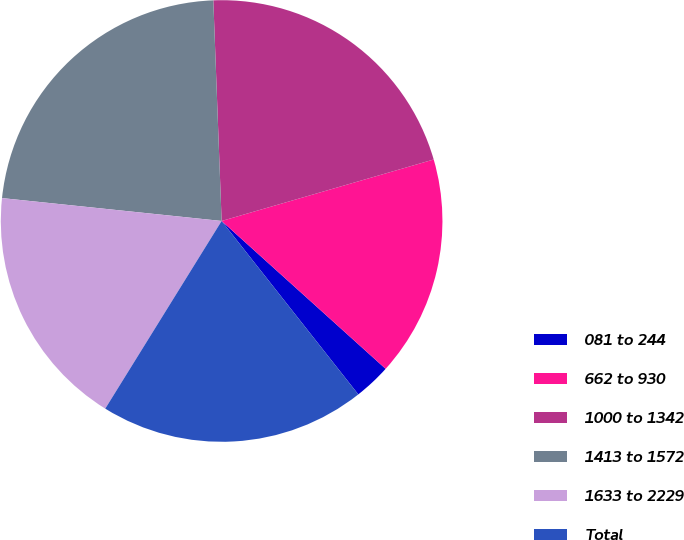Convert chart. <chart><loc_0><loc_0><loc_500><loc_500><pie_chart><fcel>081 to 244<fcel>662 to 930<fcel>1000 to 1342<fcel>1413 to 1572<fcel>1633 to 2229<fcel>Total<nl><fcel>2.7%<fcel>16.17%<fcel>21.11%<fcel>22.75%<fcel>17.82%<fcel>19.46%<nl></chart> 